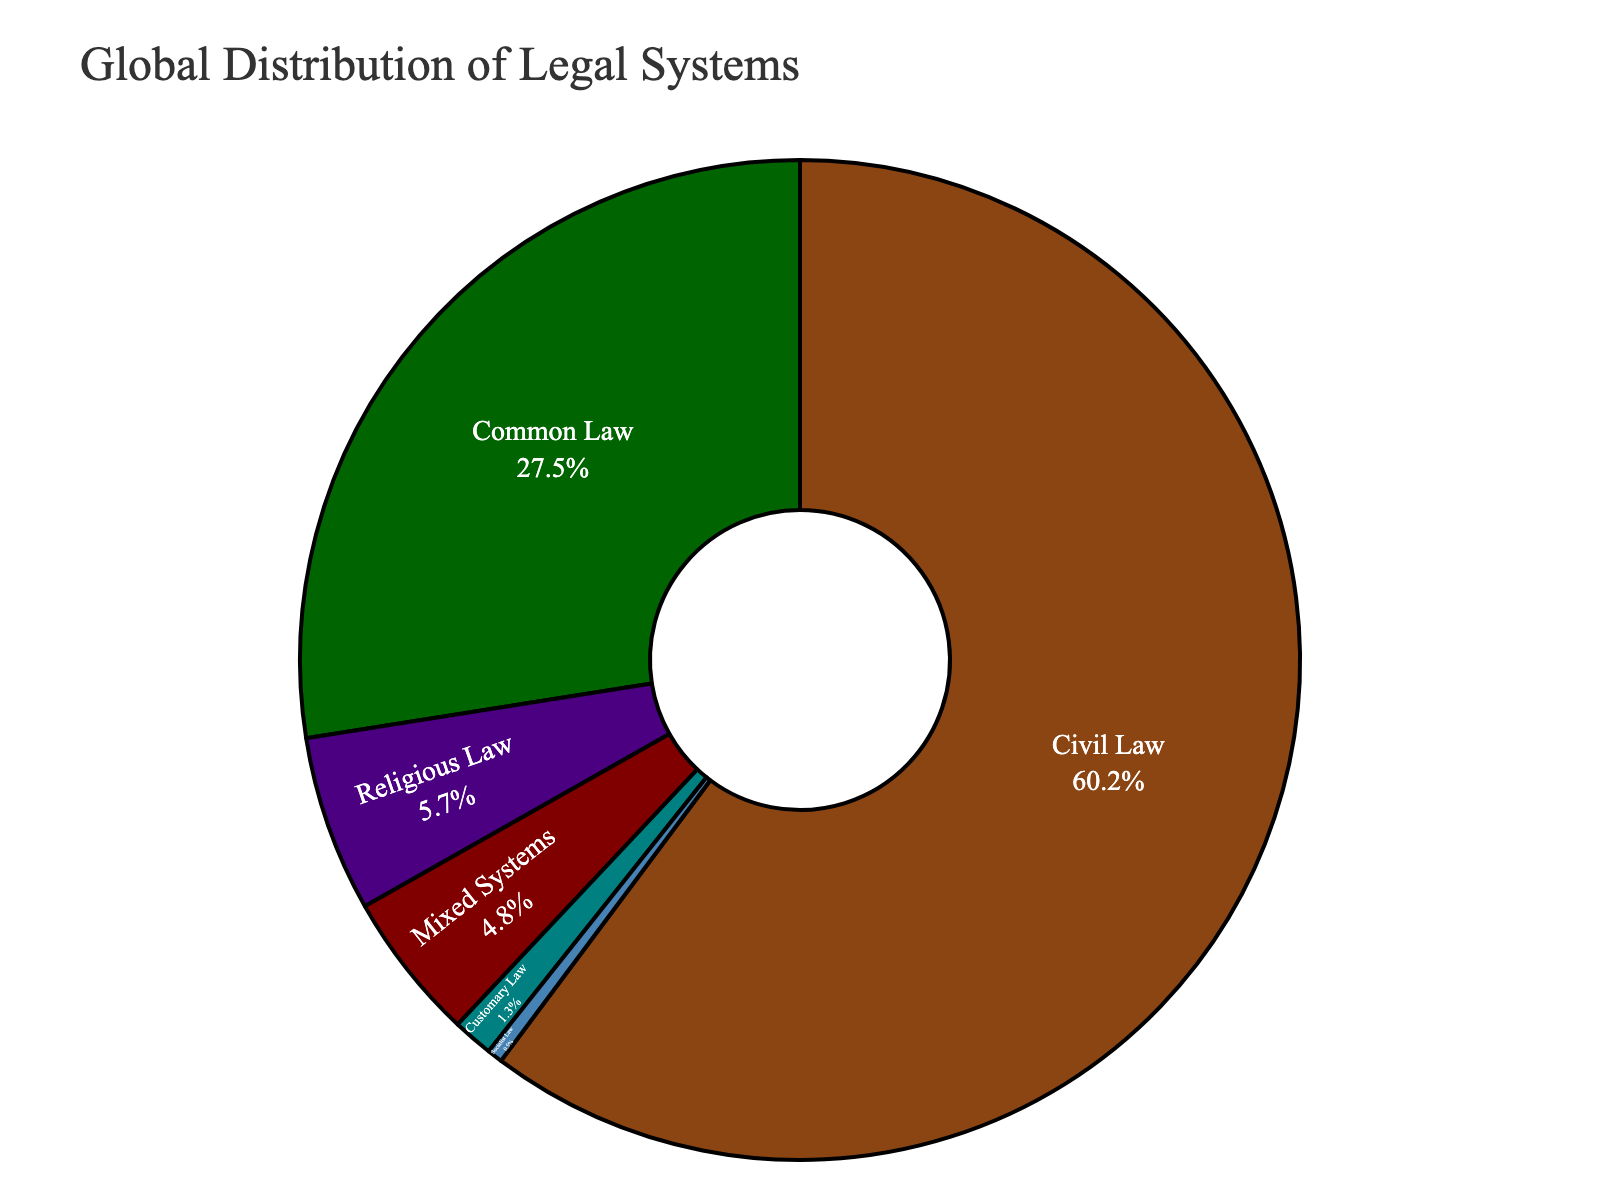what percentage of countries use Civil Law? Civil Law makes up one of the sectors within the pie chart. The corresponding text information inside the Civil Law segment shows 60.2%.
Answer: 60.2% How much larger is the percentage of countries using Common Law compared to those using Religious Law? From the pie chart, the percentage of countries using Common Law is 27.5%, and for those using Religious Law, it is 5.7%. The difference is calculated as 27.5% - 5.7%.
Answer: 21.8% Which legal system is the least common globally? By examining the size of each segment in the pie chart, Socialist Law appears to be the smallest segment with 0.5%.
Answer: Socialist Law What proportion of the global legal systems is made up by Mixed Systems and Customary Law combined? The percentages for Mixed Systems and Customary Law are 4.8% and 1.3% respectively. Adding these together gives 4.8% + 1.3%.
Answer: 6.1% If you were to combine the percentages of Common Law, Religious Law, and Customary Law, what would be the resulting value? Adding the percentages of Common Law (27.5%), Religious Law (5.7%), and Customary Law (1.3%) results in 27.5% + 5.7% + 1.3%.
Answer: 34.5% Which legal system occupies the largest portion of the chart and what is its color? The largest portion of the pie chart is taken by Civil Law. The visual representation uses a green color for Civil Law.
Answer: Civil Law, green Between Civil Law and Mixed Systems, which one has a higher percentage, and how much more? Civil Law has a percentage of 60.2%, while Mixed Systems have 4.8%. The difference in their percentages is 60.2% - 4.8%.
Answer: Civil Law, 55.4% What is the total percentage represented by the three least common legal systems? The three least common legal systems are Socialist Law (0.5%), Customary Law (1.3%), and Mixed Systems (4.8%). Adding these percentages gives 0.5% + 1.3% + 4.8%.
Answer: 6.6% Which legal system occupies the brown-colored segment? The pie chart segment colored brown corresponds to Common Law.
Answer: Common Law 